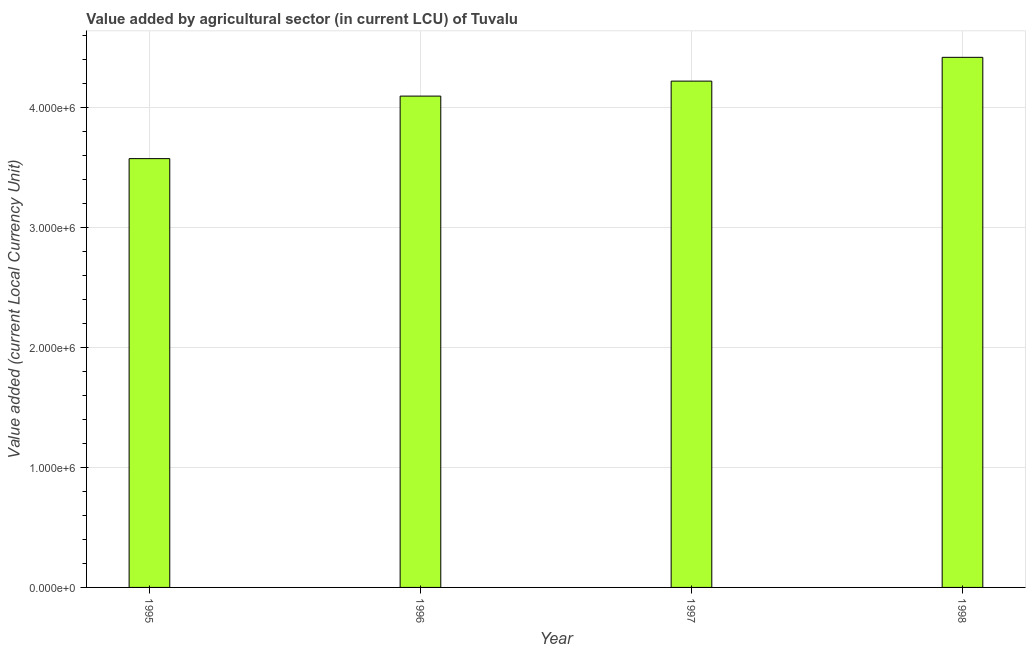Does the graph contain grids?
Offer a terse response. Yes. What is the title of the graph?
Your response must be concise. Value added by agricultural sector (in current LCU) of Tuvalu. What is the label or title of the Y-axis?
Keep it short and to the point. Value added (current Local Currency Unit). What is the value added by agriculture sector in 1996?
Provide a succinct answer. 4.10e+06. Across all years, what is the maximum value added by agriculture sector?
Your answer should be compact. 4.42e+06. Across all years, what is the minimum value added by agriculture sector?
Your response must be concise. 3.58e+06. In which year was the value added by agriculture sector minimum?
Ensure brevity in your answer.  1995. What is the sum of the value added by agriculture sector?
Ensure brevity in your answer.  1.63e+07. What is the difference between the value added by agriculture sector in 1996 and 1998?
Offer a terse response. -3.23e+05. What is the average value added by agriculture sector per year?
Offer a very short reply. 4.08e+06. What is the median value added by agriculture sector?
Your response must be concise. 4.16e+06. In how many years, is the value added by agriculture sector greater than 2200000 LCU?
Provide a short and direct response. 4. What is the ratio of the value added by agriculture sector in 1995 to that in 1996?
Your response must be concise. 0.87. What is the difference between the highest and the second highest value added by agriculture sector?
Offer a terse response. 1.98e+05. Is the sum of the value added by agriculture sector in 1995 and 1997 greater than the maximum value added by agriculture sector across all years?
Offer a very short reply. Yes. What is the difference between the highest and the lowest value added by agriculture sector?
Keep it short and to the point. 8.45e+05. In how many years, is the value added by agriculture sector greater than the average value added by agriculture sector taken over all years?
Offer a terse response. 3. How many bars are there?
Give a very brief answer. 4. Are all the bars in the graph horizontal?
Keep it short and to the point. No. How many years are there in the graph?
Keep it short and to the point. 4. What is the difference between two consecutive major ticks on the Y-axis?
Keep it short and to the point. 1.00e+06. What is the Value added (current Local Currency Unit) in 1995?
Offer a very short reply. 3.58e+06. What is the Value added (current Local Currency Unit) of 1996?
Ensure brevity in your answer.  4.10e+06. What is the Value added (current Local Currency Unit) in 1997?
Your response must be concise. 4.22e+06. What is the Value added (current Local Currency Unit) of 1998?
Provide a short and direct response. 4.42e+06. What is the difference between the Value added (current Local Currency Unit) in 1995 and 1996?
Provide a short and direct response. -5.22e+05. What is the difference between the Value added (current Local Currency Unit) in 1995 and 1997?
Ensure brevity in your answer.  -6.46e+05. What is the difference between the Value added (current Local Currency Unit) in 1995 and 1998?
Ensure brevity in your answer.  -8.45e+05. What is the difference between the Value added (current Local Currency Unit) in 1996 and 1997?
Offer a very short reply. -1.25e+05. What is the difference between the Value added (current Local Currency Unit) in 1996 and 1998?
Offer a terse response. -3.23e+05. What is the difference between the Value added (current Local Currency Unit) in 1997 and 1998?
Make the answer very short. -1.98e+05. What is the ratio of the Value added (current Local Currency Unit) in 1995 to that in 1996?
Give a very brief answer. 0.87. What is the ratio of the Value added (current Local Currency Unit) in 1995 to that in 1997?
Provide a succinct answer. 0.85. What is the ratio of the Value added (current Local Currency Unit) in 1995 to that in 1998?
Keep it short and to the point. 0.81. What is the ratio of the Value added (current Local Currency Unit) in 1996 to that in 1997?
Offer a terse response. 0.97. What is the ratio of the Value added (current Local Currency Unit) in 1996 to that in 1998?
Offer a terse response. 0.93. What is the ratio of the Value added (current Local Currency Unit) in 1997 to that in 1998?
Your answer should be very brief. 0.95. 